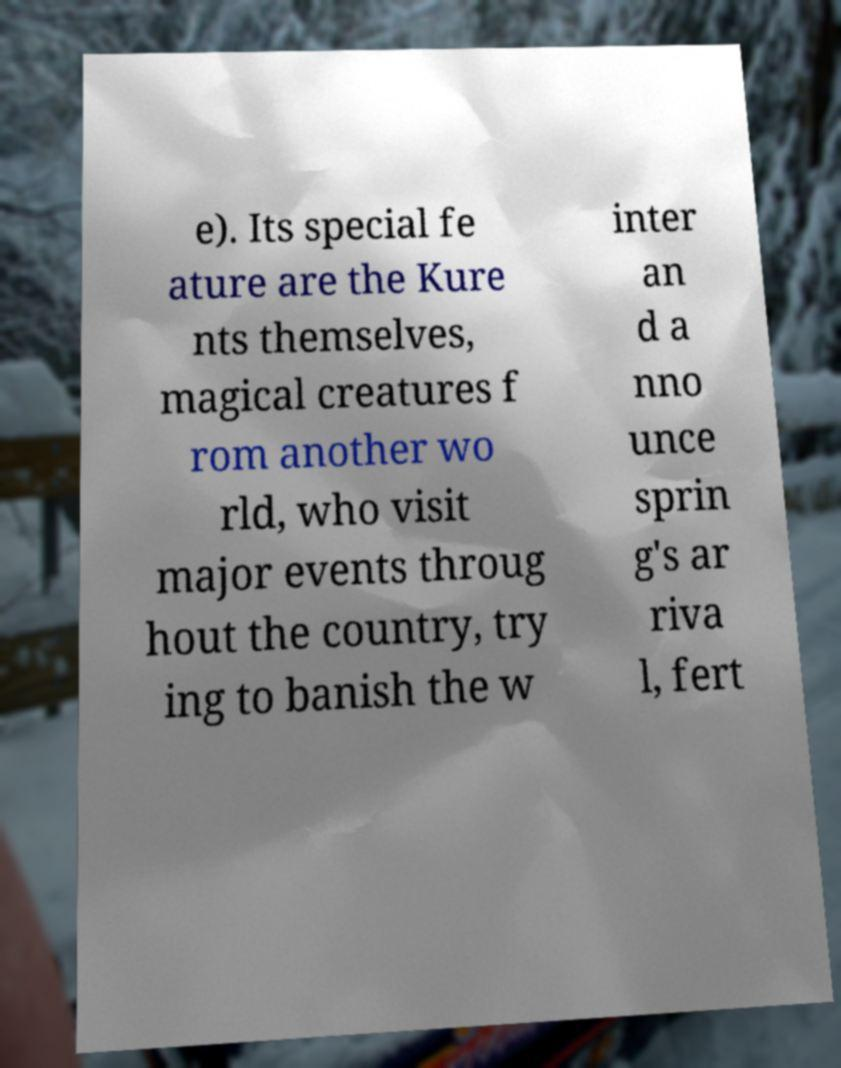Could you assist in decoding the text presented in this image and type it out clearly? e). Its special fe ature are the Kure nts themselves, magical creatures f rom another wo rld, who visit major events throug hout the country, try ing to banish the w inter an d a nno unce sprin g's ar riva l, fert 